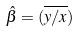<formula> <loc_0><loc_0><loc_500><loc_500>\hat { \beta } = ( \overline { y / x } )</formula> 